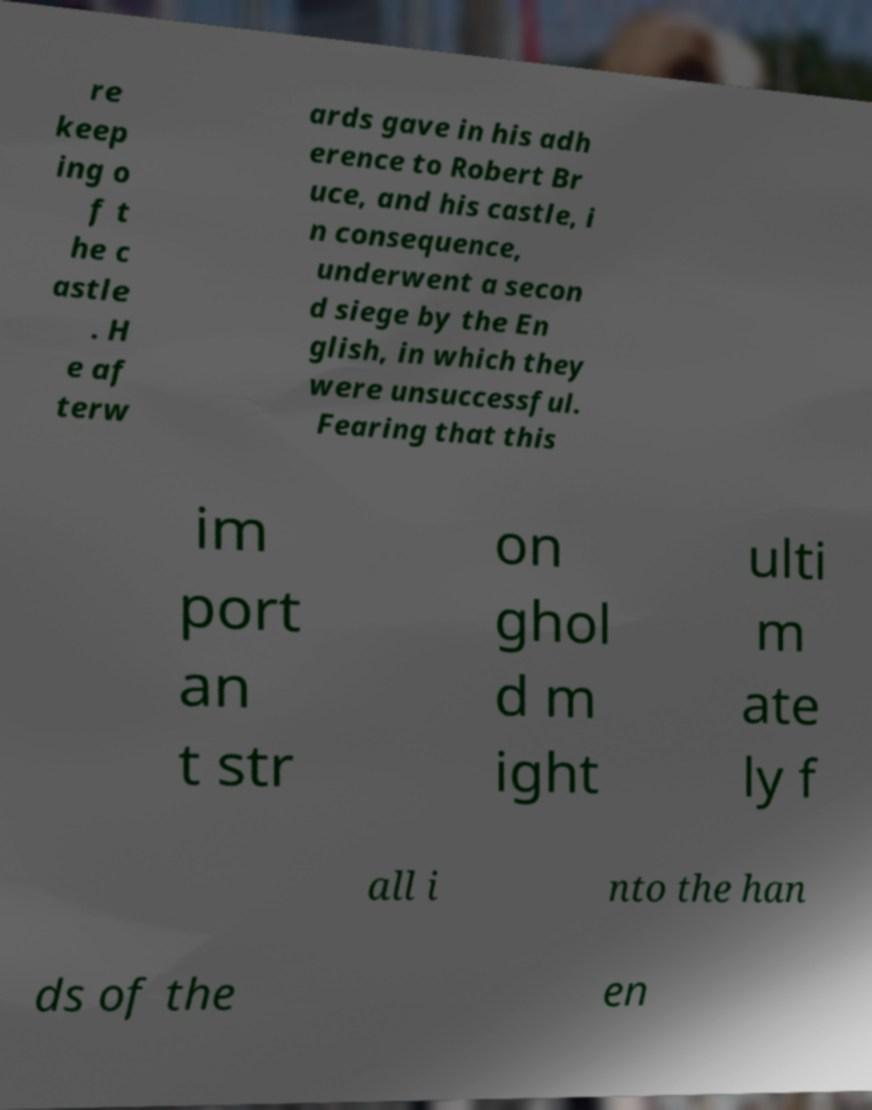Can you accurately transcribe the text from the provided image for me? re keep ing o f t he c astle . H e af terw ards gave in his adh erence to Robert Br uce, and his castle, i n consequence, underwent a secon d siege by the En glish, in which they were unsuccessful. Fearing that this im port an t str on ghol d m ight ulti m ate ly f all i nto the han ds of the en 